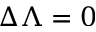<formula> <loc_0><loc_0><loc_500><loc_500>\Delta \Lambda = 0</formula> 